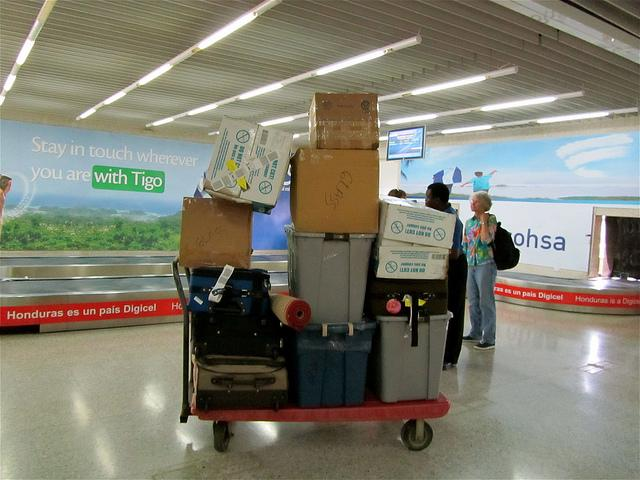What country is this venue situated in? Please explain your reasoning. honduras. The word honduras is clearly visible on the baggage claim. baggage claims are usually situated in airports and when country names are written on a permanent fixture in an airport it is likely the name of the country the airport is in. 